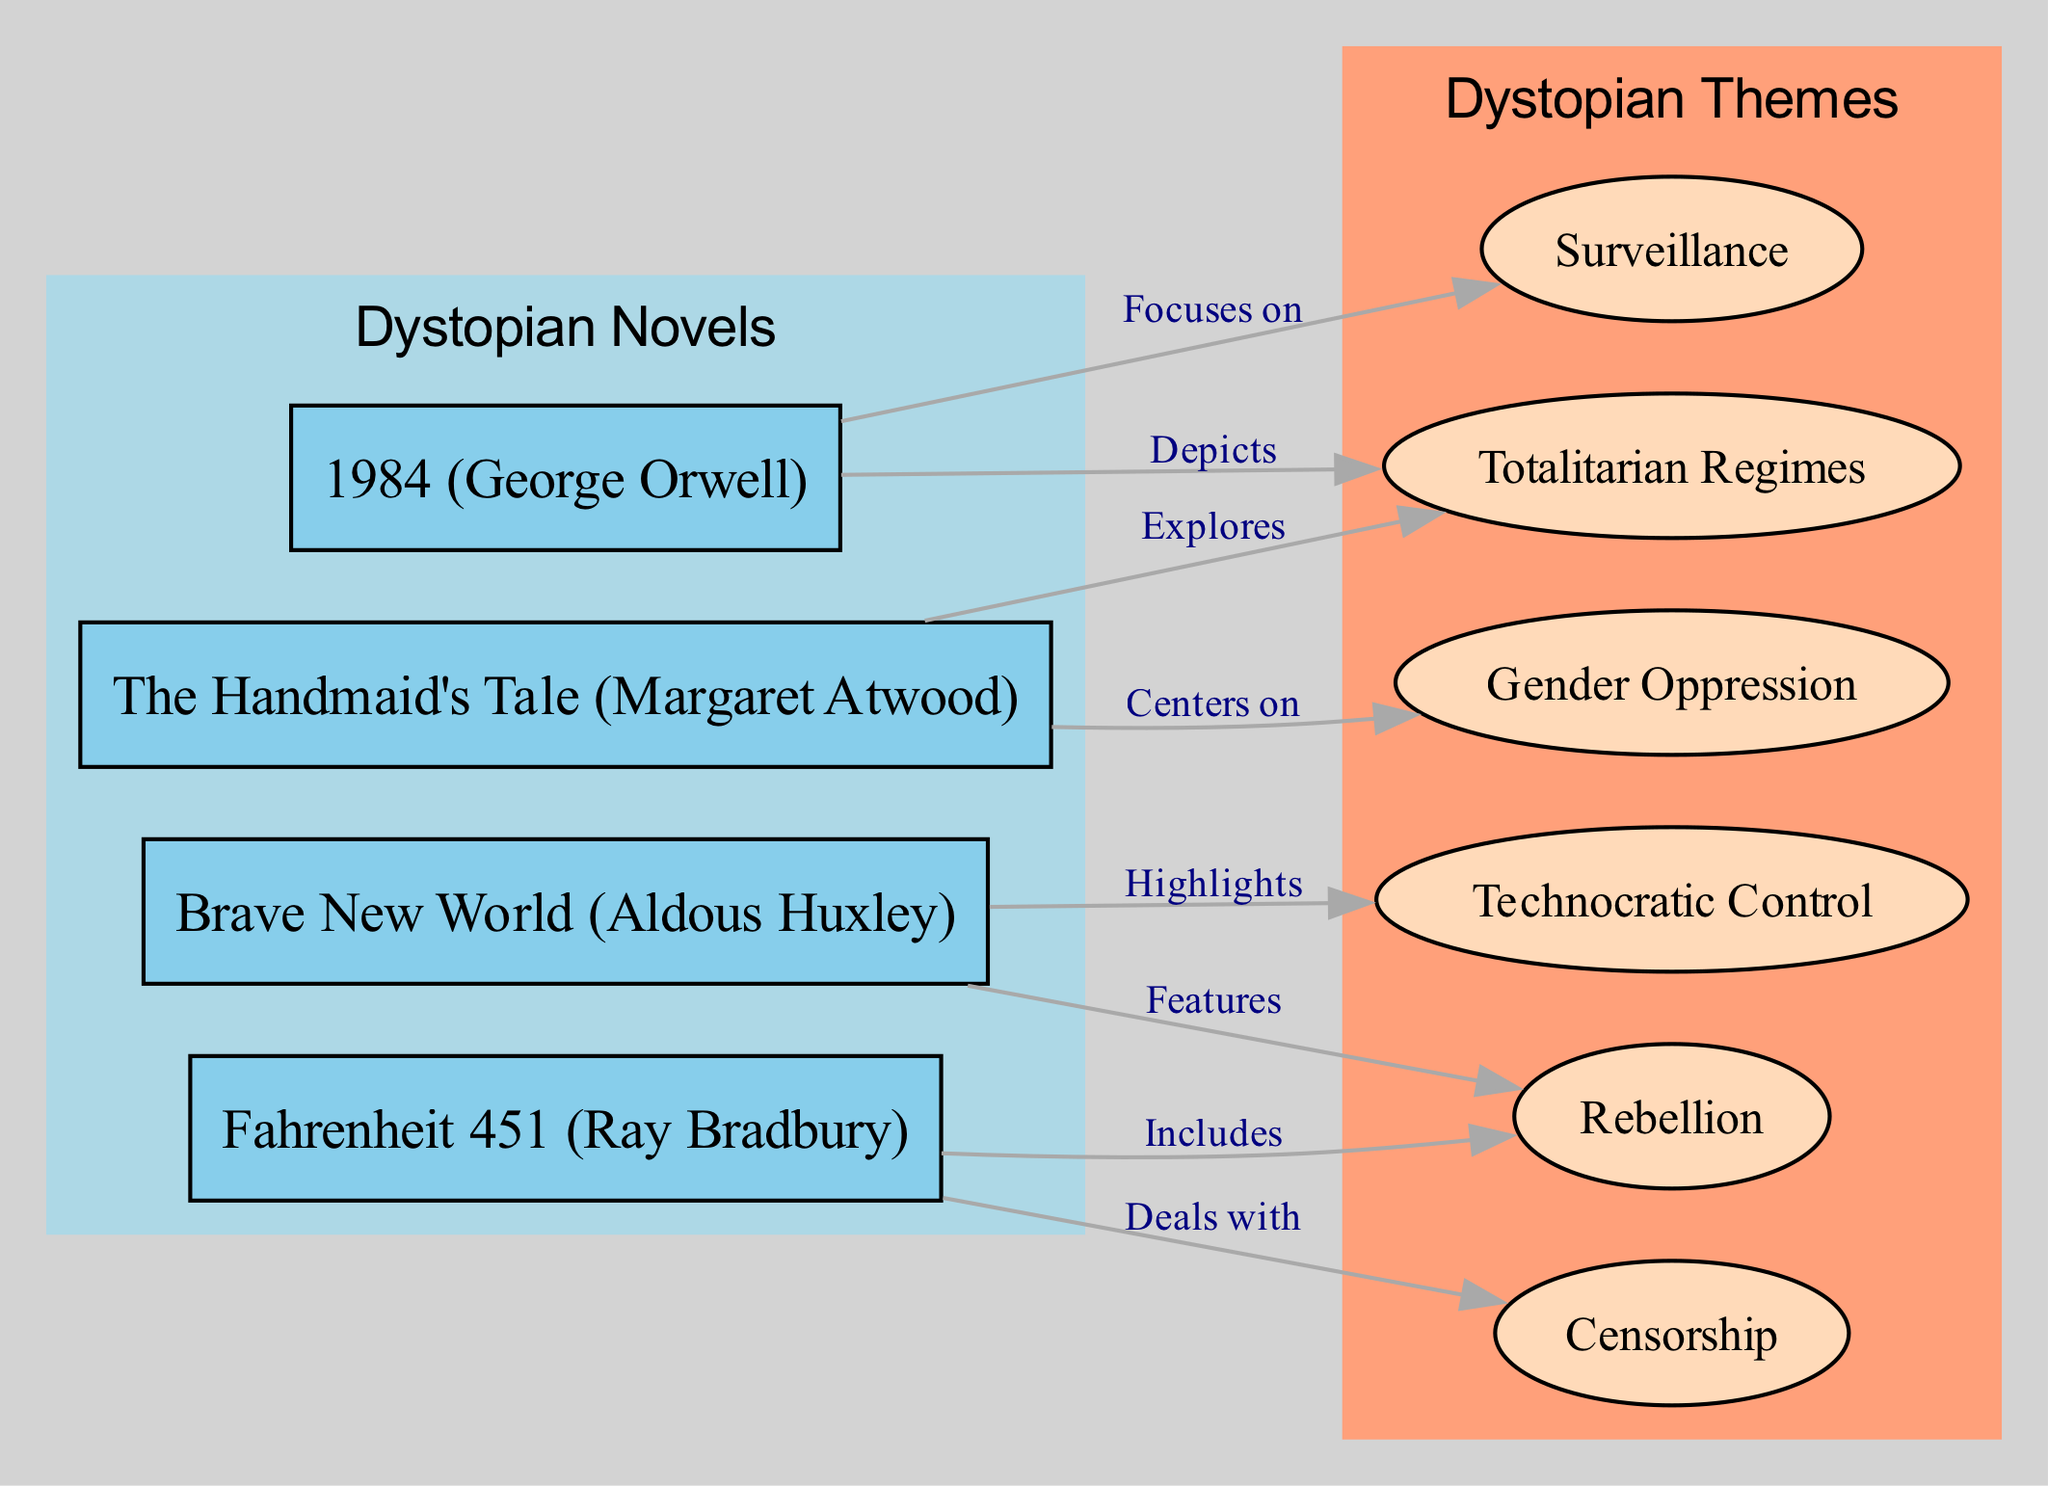What is the total number of dystopian novels represented in the diagram? The diagram includes four novels: "1984," "Brave New World," "Fahrenheit 451," and "The Handmaid's Tale." Counting these, we find there are four distinct nodes representing dystopian novels.
Answer: 4 Which theme is a focus in George Orwell's "1984"? In the diagram, the edge connecting "1984" to "Surveillance" is labeled "Focuses on," indicating that "Surveillance" is a primary theme depicted in "1984."
Answer: Surveillance What does Aldous Huxley's "Brave New World" highlight? The edge from "Brave New World" to "Technocratic Control" is labeled "Highlights," showing that this is a key theme in the novel.
Answer: Technocratic Control How many themes are associated with Ray Bradbury's "Fahrenheit 451"? "Fahrenheit 451" has two edges: one to "Censorship" (labeled "Deals with") and another to "Rebellion" (labeled "Includes"). This means there are two themes associated with "Fahrenheit 451."
Answer: 2 Which theme centers on gender issues as shown in the diagram? The edge leading from "The Handmaid's Tale" to "Gender Oppression" is labeled "Centers on," indicating that this theme focuses specifically on gender issues.
Answer: Gender Oppression What is the relationship between "The Handmaid's Tale" and "Totalitarian Regimes"? The edge from "HandmaidsTale" to "TotalitarianRegimes" is labeled "Explores," showing a direct relationship where "The Handmaid's Tale" investigates themes related to totalitarian regimes.
Answer: Explores Which novel features rebellion as a key element? Both "Brave New World" and "Fahrenheit 451" include rebellion as a theme. The diagram shows edges labeled "Features" and "Includes," respectively, indicating that both novels involve rebellion prominently.
Answer: Brave New World, Fahrenheit 451 Is there a theme that connects all the dystopian novels shown? While none of the themes connect all novels directly, "Rebellion" is associated with both "Brave New World" and "Fahrenheit 451," indicating it may be a recurring theme across some dystopian works, but not all. Thus, a specific theme uniting all novels does not exist.
Answer: No How many edges are there indicating relationships between novels and themes? The diagram outlines a total of seven edges that connect the four novels to their respective themes, showing how these literary works relate to the overarching themes of dystopian fiction.
Answer: 7 